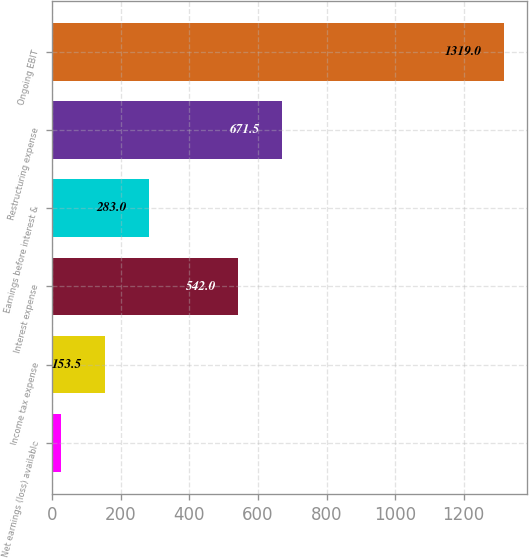<chart> <loc_0><loc_0><loc_500><loc_500><bar_chart><fcel>Net earnings (loss) available<fcel>Income tax expense<fcel>Interest expense<fcel>Earnings before interest &<fcel>Restructuring expense<fcel>Ongoing EBIT<nl><fcel>24<fcel>153.5<fcel>542<fcel>283<fcel>671.5<fcel>1319<nl></chart> 